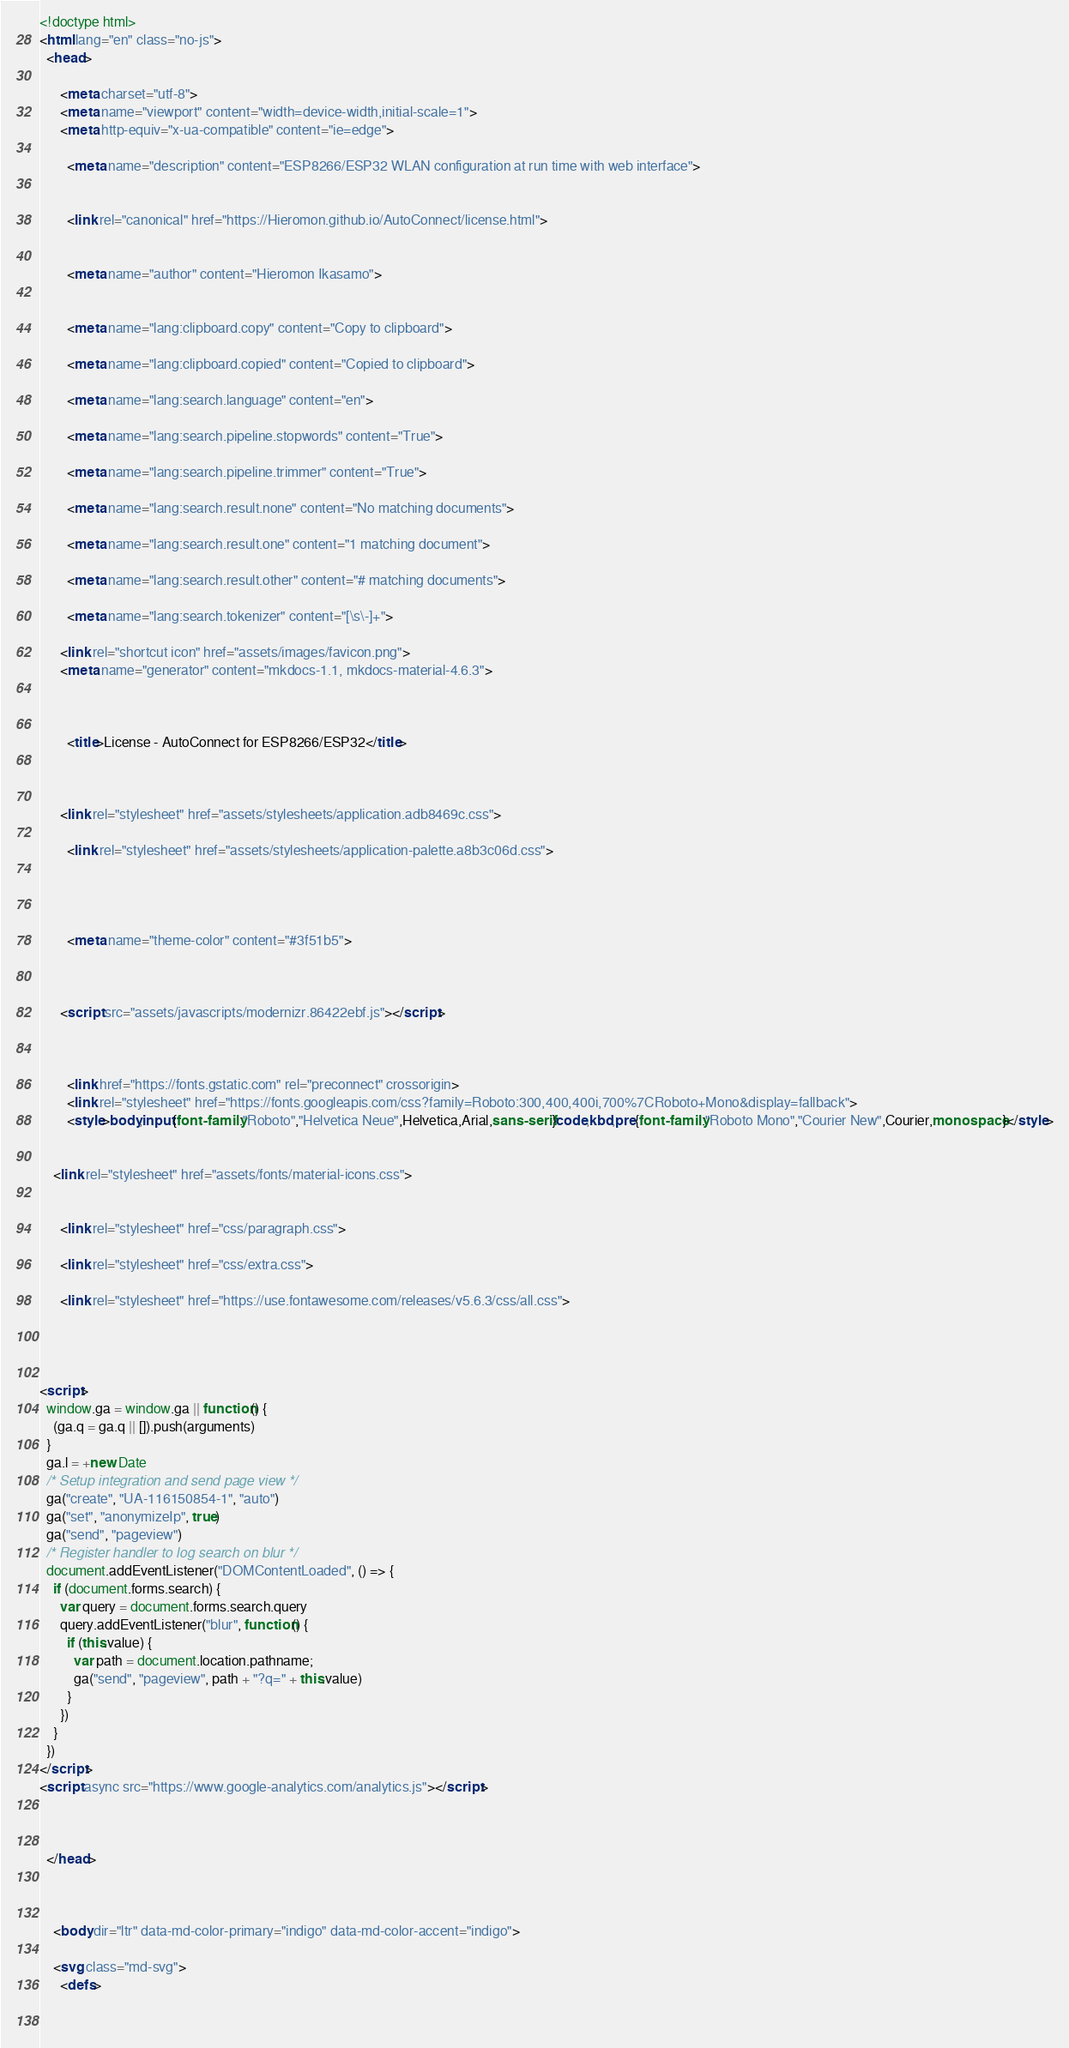Convert code to text. <code><loc_0><loc_0><loc_500><loc_500><_HTML_>



<!doctype html>
<html lang="en" class="no-js">
  <head>
    
      <meta charset="utf-8">
      <meta name="viewport" content="width=device-width,initial-scale=1">
      <meta http-equiv="x-ua-compatible" content="ie=edge">
      
        <meta name="description" content="ESP8266/ESP32 WLAN configuration at run time with web interface">
      
      
        <link rel="canonical" href="https://Hieromon.github.io/AutoConnect/license.html">
      
      
        <meta name="author" content="Hieromon Ikasamo">
      
      
        <meta name="lang:clipboard.copy" content="Copy to clipboard">
      
        <meta name="lang:clipboard.copied" content="Copied to clipboard">
      
        <meta name="lang:search.language" content="en">
      
        <meta name="lang:search.pipeline.stopwords" content="True">
      
        <meta name="lang:search.pipeline.trimmer" content="True">
      
        <meta name="lang:search.result.none" content="No matching documents">
      
        <meta name="lang:search.result.one" content="1 matching document">
      
        <meta name="lang:search.result.other" content="# matching documents">
      
        <meta name="lang:search.tokenizer" content="[\s\-]+">
      
      <link rel="shortcut icon" href="assets/images/favicon.png">
      <meta name="generator" content="mkdocs-1.1, mkdocs-material-4.6.3">
    
    
      
        <title>License - AutoConnect for ESP8266/ESP32</title>
      
    
    
      <link rel="stylesheet" href="assets/stylesheets/application.adb8469c.css">
      
        <link rel="stylesheet" href="assets/stylesheets/application-palette.a8b3c06d.css">
      
      
        
        
        <meta name="theme-color" content="#3f51b5">
      
    
    
      <script src="assets/javascripts/modernizr.86422ebf.js"></script>
    
    
      
        <link href="https://fonts.gstatic.com" rel="preconnect" crossorigin>
        <link rel="stylesheet" href="https://fonts.googleapis.com/css?family=Roboto:300,400,400i,700%7CRoboto+Mono&display=fallback">
        <style>body,input{font-family:"Roboto","Helvetica Neue",Helvetica,Arial,sans-serif}code,kbd,pre{font-family:"Roboto Mono","Courier New",Courier,monospace}</style>
      
    
    <link rel="stylesheet" href="assets/fonts/material-icons.css">
    
    
      <link rel="stylesheet" href="css/paragraph.css">
    
      <link rel="stylesheet" href="css/extra.css">
    
      <link rel="stylesheet" href="https://use.fontawesome.com/releases/v5.6.3/css/all.css">
    
    
      
        
<script>
  window.ga = window.ga || function() {
    (ga.q = ga.q || []).push(arguments)
  }
  ga.l = +new Date
  /* Setup integration and send page view */
  ga("create", "UA-116150854-1", "auto")
  ga("set", "anonymizeIp", true)
  ga("send", "pageview")
  /* Register handler to log search on blur */
  document.addEventListener("DOMContentLoaded", () => {
    if (document.forms.search) {
      var query = document.forms.search.query
      query.addEventListener("blur", function() {
        if (this.value) {
          var path = document.location.pathname;
          ga("send", "pageview", path + "?q=" + this.value)
        }
      })
    }
  })
</script>
<script async src="https://www.google-analytics.com/analytics.js"></script>
      
    
    
  </head>
  
    
    
    <body dir="ltr" data-md-color-primary="indigo" data-md-color-accent="indigo">
  
    <svg class="md-svg">
      <defs>
        
        </code> 